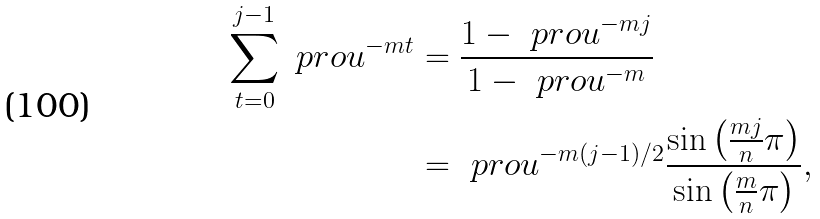Convert formula to latex. <formula><loc_0><loc_0><loc_500><loc_500>\sum _ { t = 0 } ^ { j - 1 } \ p r o u ^ { - m t } & = \frac { 1 - \ p r o u ^ { - m j } } { 1 - \ p r o u ^ { - m } } \\ & = \ p r o u ^ { - m ( j - 1 ) / 2 } \frac { \sin \left ( \frac { m j } n \pi \right ) } { \sin \left ( \frac { m } { n } \pi \right ) } ,</formula> 